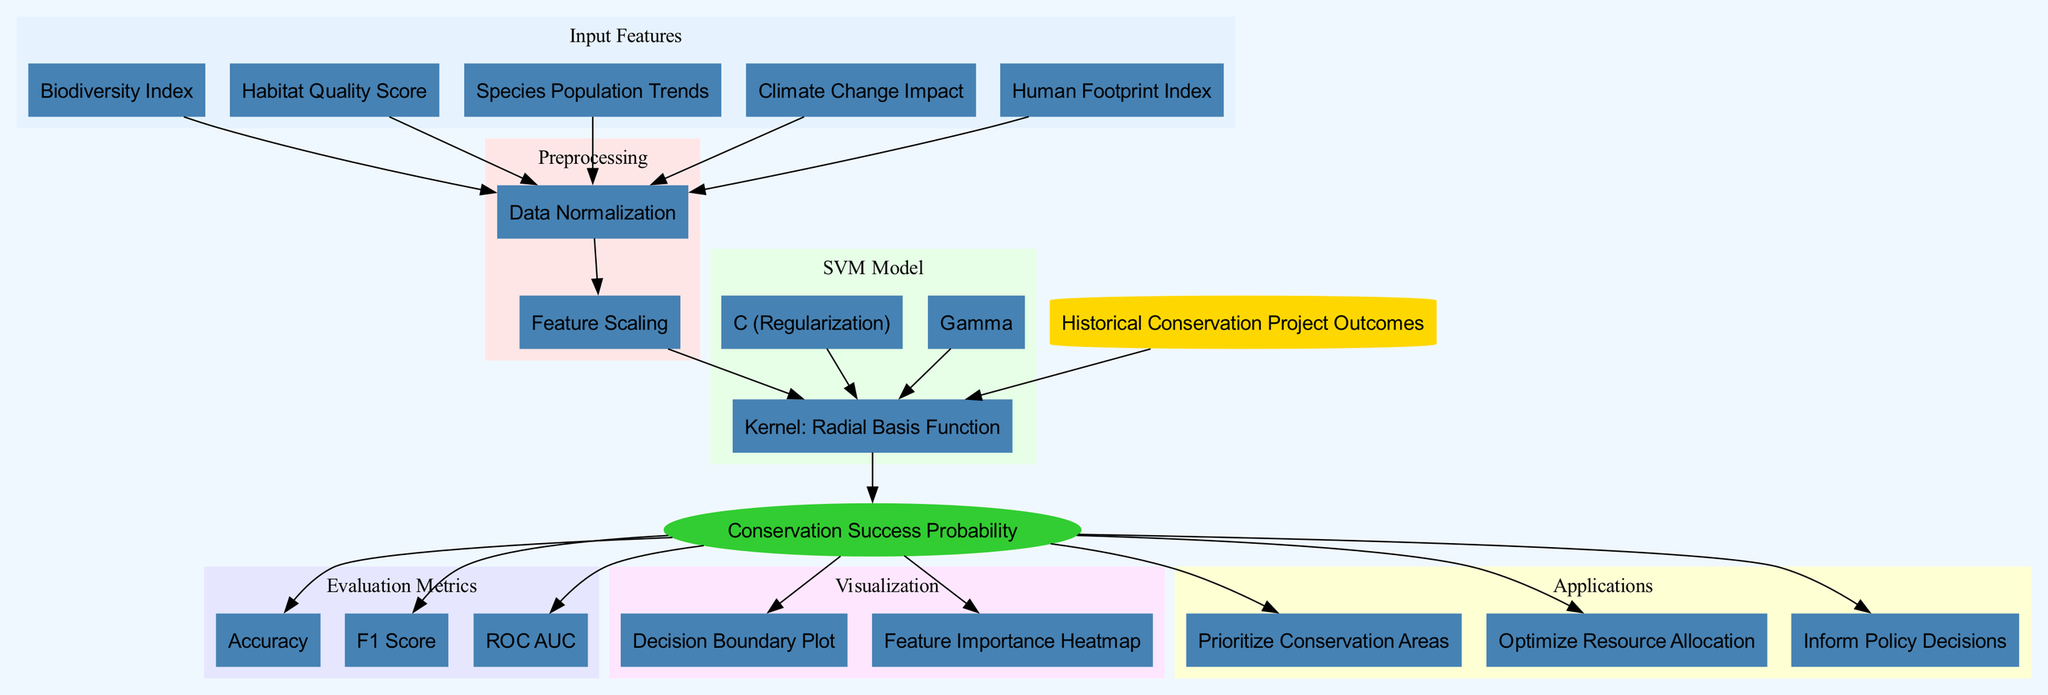What are the input features used in the model? The diagram lists five input features: Biodiversity Index, Habitat Quality Score, Species Population Trends, Climate Change Impact, and Human Footprint Index. These are directly connected to the preprocessing step.
Answer: Biodiversity Index, Habitat Quality Score, Species Population Trends, Climate Change Impact, Human Footprint Index What type of SVM kernel is used in this model? The diagram specifies that the kernel used for the SVM model is the Radial Basis Function, which is mentioned in the SVM Model cluster.
Answer: Radial Basis Function How many evaluation metrics are listed in the diagram? There are three evaluation metrics shown in the Evaluation Metrics cluster: Accuracy, F1 Score, and ROC AUC. Therefore, counting these gives us a total of three metrics.
Answer: Three What preprocessing steps are involved before feeding the data into the SVM model? The diagram depicts a sequence of two preprocessing steps: Data Normalization followed by Feature Scaling, indicating the order of operations.
Answer: Data Normalization, Feature Scaling Which input feature would most likely correlate with the Human Footprint Index in predicting conservation success? The model includes indicators like Habitat Quality Score, Climate Change Impact, and Species Population Trends which likely correlate with the Human Footprint Index, as they all pertain to ecological conditions. Analyzing the relationships provides insights into this.
Answer: Habitat Quality Score, Climate Change Impact, Species Population Trends What is the final output of the support vector machine model? According to the diagram, the final output of the SVM model is the Conservation Success Probability, indicating what the model predicts as a result of processing the training data through the SVM.
Answer: Conservation Success Probability What connections relate the output to the evaluation metrics? The flow from the output node (Conservation Success Probability) leads directly to three nodes in the Evaluation Metrics cluster: Accuracy, F1 Score, and ROC AUC. This shows how the success probability is measured through these metrics.
Answer: Accuracy, F1 Score, ROC AUC What applications can be derived from the output of the model? The diagram lists three applications stemming from the output: Prioritize Conservation Areas, Optimize Resource Allocation, and Inform Policy Decisions, showing the practical uses of the model's predictions.
Answer: Prioritize Conservation Areas, Optimize Resource Allocation, Inform Policy Decisions 